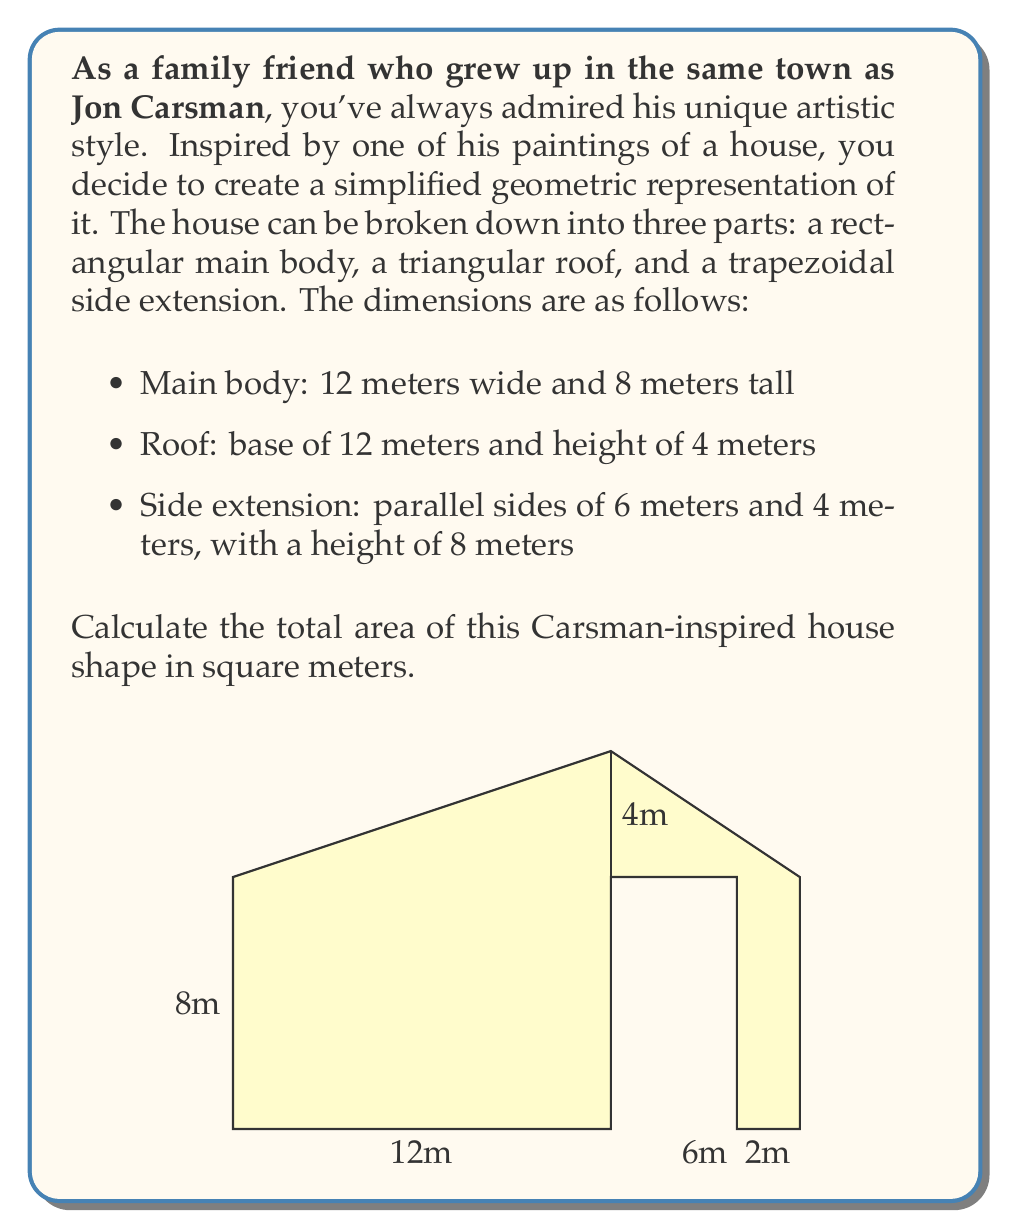Provide a solution to this math problem. To solve this problem, we need to calculate the area of each part separately and then sum them up:

1. Area of the main body (rectangle):
   $$A_1 = width \times height = 12 \times 8 = 96 \text{ m}^2$$

2. Area of the roof (triangle):
   $$A_2 = \frac{1}{2} \times base \times height = \frac{1}{2} \times 12 \times 4 = 24 \text{ m}^2$$

3. Area of the side extension (trapezoid):
   The formula for the area of a trapezoid is:
   $$A = \frac{a + b}{2} \times h$$
   where $a$ and $b$ are the parallel sides and $h$ is the height.
   
   $$A_3 = \frac{6 + 4}{2} \times 8 = 5 \times 8 = 40 \text{ m}^2$$

Now, we sum up all the areas:

$$A_{total} = A_1 + A_2 + A_3 = 96 + 24 + 40 = 160 \text{ m}^2$$

Therefore, the total area of the Carsman-inspired house shape is 160 square meters.
Answer: 160 m² 